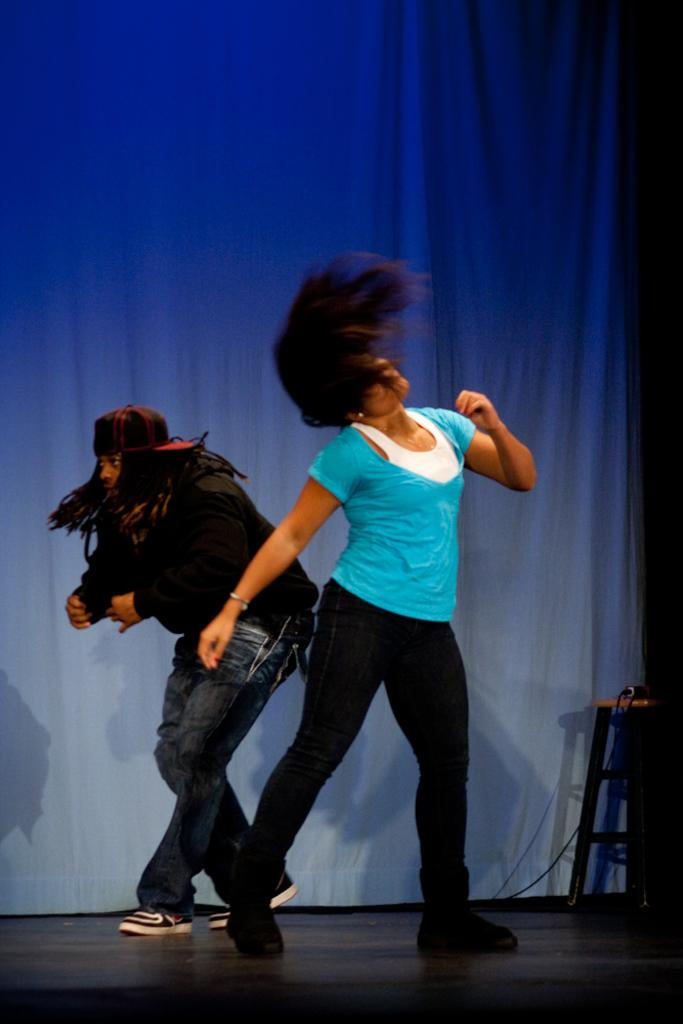What are the two persons in the image doing? The two persons in the image are dancing. What can be seen in the background of the image? There is a curtain in the background of the image. What object is on the right side of the image? There is a stool on the right side of the image. How many cars can be seen in the image? There are no cars present in the image. What type of cow is visible in the image? There is no cow present in the image. 